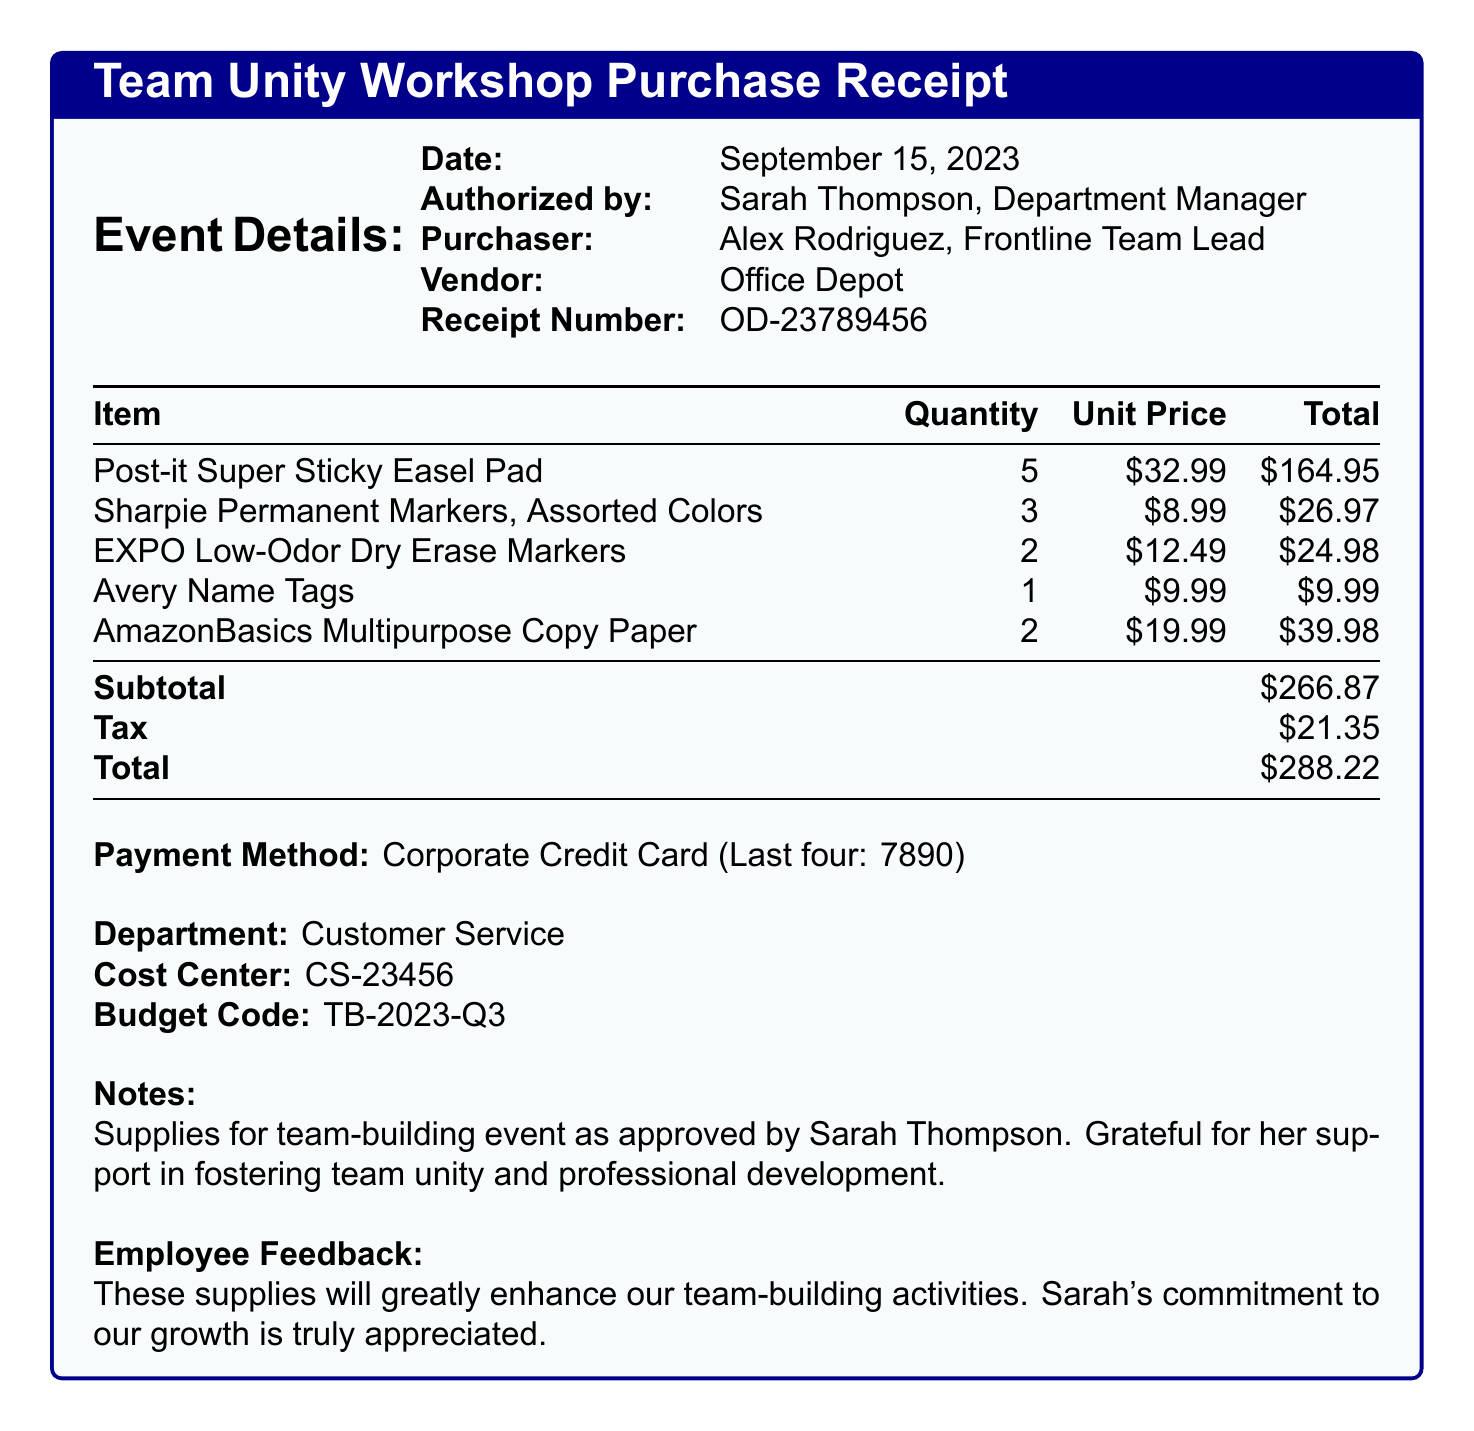What is the event name? The event name is listed at the beginning of the document, which is the "Team Unity Workshop."
Answer: Team Unity Workshop Who authorized the purchase? The document states that the purchase was authorized by Sarah Thompson, who is the Department Manager.
Answer: Sarah Thompson, Department Manager What is the total amount spent? The total amount is itemized near the end of the document, indicating the overall expenditure, which is $288.22.
Answer: $288.22 How many Post-it Super Sticky Easel Pads were purchased? The quantity of Post-it Super Sticky Easel Pads is provided in the item list, where it shows that 5 were purchased.
Answer: 5 What is the payment method used? The payment method is clearly mentioned in the document, stating that it was a Corporate Credit Card.
Answer: Corporate Credit Card What is the subtotal before tax? The subtotal is given in the financial summary section, which amounts to $266.87.
Answer: $266.87 What department is associated with this transaction? The department information is included in the document and indicates it is the Customer Service department.
Answer: Customer Service What is the budget code for this expense? The budget code is specified in the latter part of the document as TB-2023-Q3.
Answer: TB-2023-Q3 What feedback did employees provide about the supplies? Employee feedback is included in the notes, expressing the value of the supplies for team activities and appreciation for supportive leadership.
Answer: These supplies will greatly enhance our team-building activities. Sarah's commitment to our growth is truly appreciated 